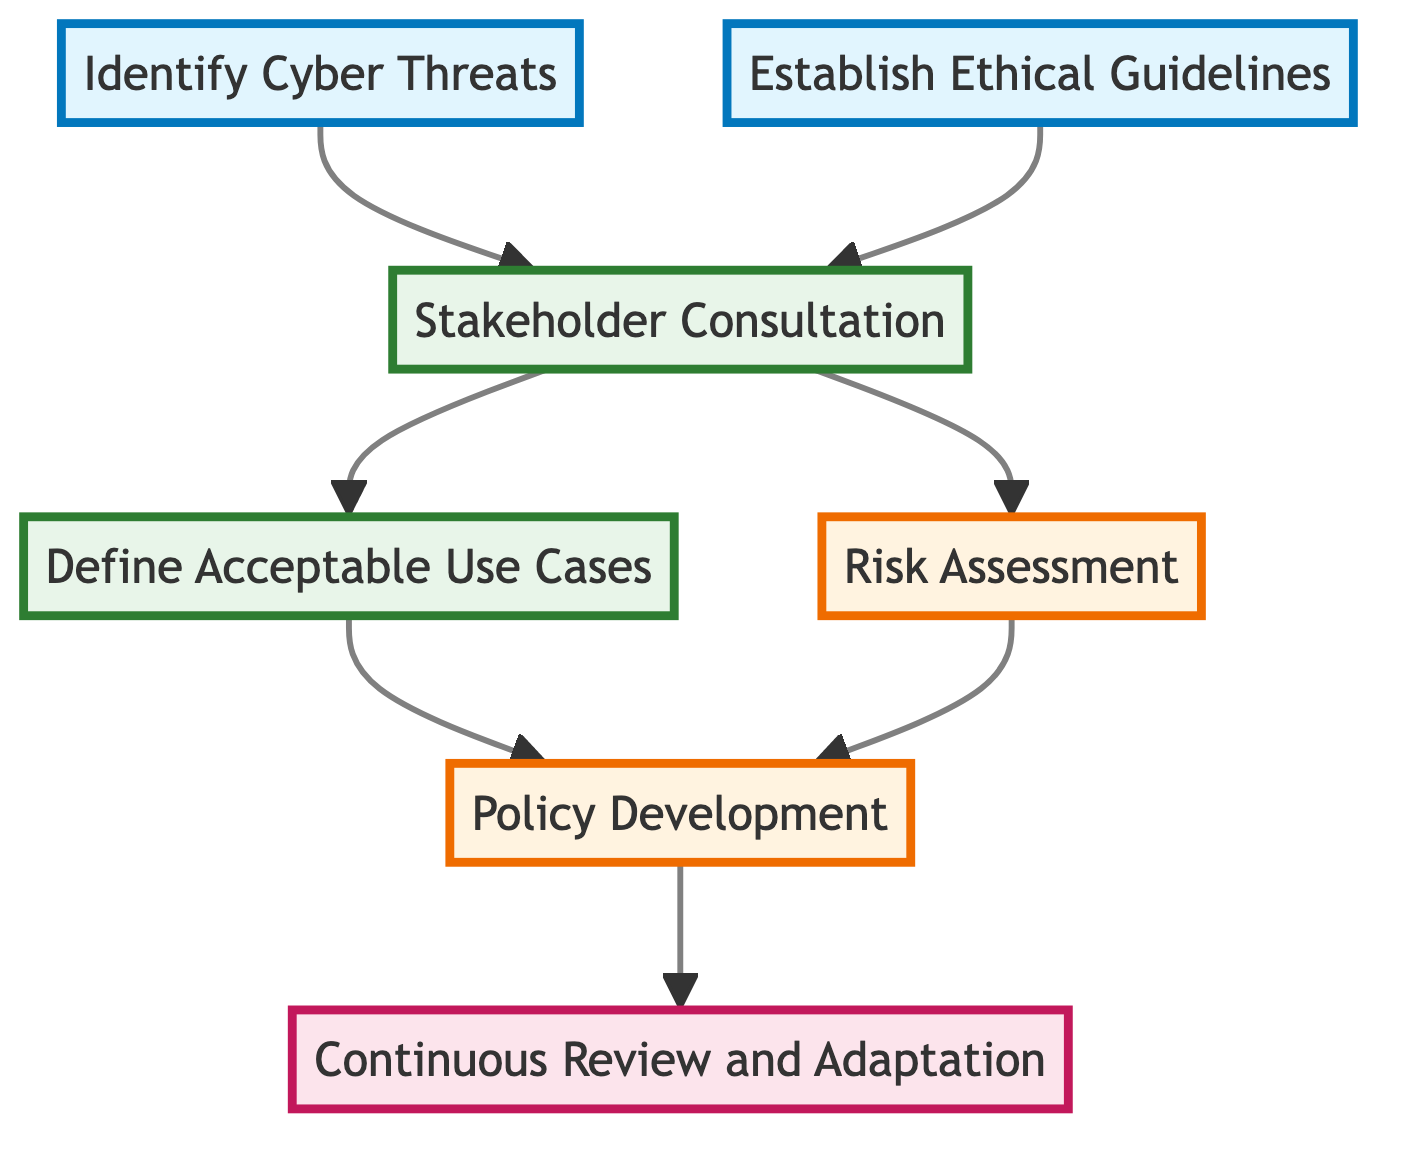What is the first step in the decision-making process? The first step in the decision-making process, as represented in the diagram, is "Identify Cyber Threats". This is indicated as the top node that initiates the flow of the process.
Answer: Identify Cyber Threats How many nodes are present in the diagram? The diagram contains a total of seven nodes as represented by each of the steps listed in the flow chart. These nodes represent distinct elements in the decision-making process.
Answer: Seven What is the relationship between "Stakeholder Consultation" and "Define Acceptable Use Cases"? "Stakeholder Consultation" connects to "Define Acceptable Use Cases" as an input; after stakeholders provide input, this leads to defining the scenarios for acceptable use of cyber capabilities in warfare.
Answer: Input What follows after "Policy Development"? After "Policy Development", the next step is "Continuous Review and Adaptation". This indicates that once policies are developed, they are subject to ongoing evaluation and changes based on new developments.
Answer: Continuous Review and Adaptation What is evaluated in the "Risk Assessment" step? In the "Risk Assessment" step, the potential risks and consequences of cyber operations are evaluated. It assesses what could happen as a result of cyber actions, considering their implications for security.
Answer: Potential risks and consequences How do ethical guidelines influence stakeholder consultation? The step "Establish Ethical Guidelines" informs "Stakeholder Consultation" by providing a framework within which stakeholders can give their input, ensuring that the participants understand the ethical considerations during discussions.
Answer: Framework Which node connects directly to both "Establish Ethical Guidelines" and "Identify Cyber Threats"? "Stakeholder Consultation" connects directly to both "Establish Ethical Guidelines" and "Identify Cyber Threats", incorporating insights from both these nodes into the consultation process.
Answer: Stakeholder Consultation What is the final outcome of the decision-making process as per the diagram? The final outcome of the decision-making process, according to the diagram, is "Continuous Review and Adaptation", indicating that the protocols established will be continuously updated as necessary.
Answer: Continuous Review and Adaptation 